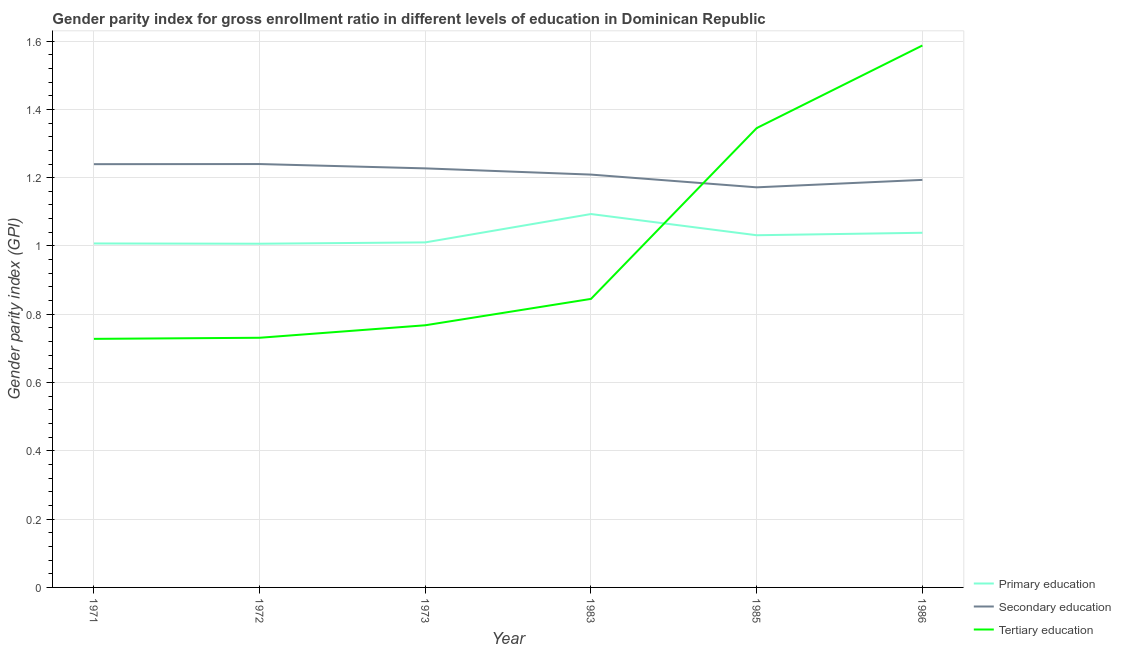Does the line corresponding to gender parity index in primary education intersect with the line corresponding to gender parity index in tertiary education?
Offer a terse response. Yes. Is the number of lines equal to the number of legend labels?
Ensure brevity in your answer.  Yes. What is the gender parity index in tertiary education in 1985?
Provide a short and direct response. 1.35. Across all years, what is the maximum gender parity index in primary education?
Your response must be concise. 1.09. Across all years, what is the minimum gender parity index in primary education?
Offer a terse response. 1.01. What is the total gender parity index in secondary education in the graph?
Give a very brief answer. 7.28. What is the difference between the gender parity index in tertiary education in 1971 and that in 1973?
Make the answer very short. -0.04. What is the difference between the gender parity index in primary education in 1983 and the gender parity index in tertiary education in 1972?
Provide a succinct answer. 0.36. What is the average gender parity index in primary education per year?
Your answer should be compact. 1.03. In the year 1971, what is the difference between the gender parity index in secondary education and gender parity index in primary education?
Your response must be concise. 0.23. What is the ratio of the gender parity index in tertiary education in 1971 to that in 1983?
Make the answer very short. 0.86. Is the difference between the gender parity index in tertiary education in 1972 and 1985 greater than the difference between the gender parity index in primary education in 1972 and 1985?
Your answer should be compact. No. What is the difference between the highest and the second highest gender parity index in tertiary education?
Provide a short and direct response. 0.24. What is the difference between the highest and the lowest gender parity index in primary education?
Your response must be concise. 0.09. In how many years, is the gender parity index in tertiary education greater than the average gender parity index in tertiary education taken over all years?
Give a very brief answer. 2. Is the gender parity index in tertiary education strictly less than the gender parity index in primary education over the years?
Provide a short and direct response. No. How many lines are there?
Keep it short and to the point. 3. How many years are there in the graph?
Provide a succinct answer. 6. Are the values on the major ticks of Y-axis written in scientific E-notation?
Ensure brevity in your answer.  No. Does the graph contain any zero values?
Your response must be concise. No. Does the graph contain grids?
Ensure brevity in your answer.  Yes. Where does the legend appear in the graph?
Your response must be concise. Bottom right. How many legend labels are there?
Make the answer very short. 3. What is the title of the graph?
Ensure brevity in your answer.  Gender parity index for gross enrollment ratio in different levels of education in Dominican Republic. Does "Female employers" appear as one of the legend labels in the graph?
Your answer should be compact. No. What is the label or title of the Y-axis?
Your answer should be compact. Gender parity index (GPI). What is the Gender parity index (GPI) of Primary education in 1971?
Your answer should be compact. 1.01. What is the Gender parity index (GPI) of Secondary education in 1971?
Give a very brief answer. 1.24. What is the Gender parity index (GPI) of Tertiary education in 1971?
Keep it short and to the point. 0.73. What is the Gender parity index (GPI) of Primary education in 1972?
Your response must be concise. 1.01. What is the Gender parity index (GPI) of Secondary education in 1972?
Your answer should be very brief. 1.24. What is the Gender parity index (GPI) of Tertiary education in 1972?
Your answer should be compact. 0.73. What is the Gender parity index (GPI) in Primary education in 1973?
Your answer should be compact. 1.01. What is the Gender parity index (GPI) of Secondary education in 1973?
Offer a terse response. 1.23. What is the Gender parity index (GPI) in Tertiary education in 1973?
Provide a succinct answer. 0.77. What is the Gender parity index (GPI) of Primary education in 1983?
Offer a very short reply. 1.09. What is the Gender parity index (GPI) of Secondary education in 1983?
Give a very brief answer. 1.21. What is the Gender parity index (GPI) in Tertiary education in 1983?
Offer a very short reply. 0.84. What is the Gender parity index (GPI) in Primary education in 1985?
Ensure brevity in your answer.  1.03. What is the Gender parity index (GPI) of Secondary education in 1985?
Make the answer very short. 1.17. What is the Gender parity index (GPI) in Tertiary education in 1985?
Your answer should be very brief. 1.35. What is the Gender parity index (GPI) of Primary education in 1986?
Make the answer very short. 1.04. What is the Gender parity index (GPI) in Secondary education in 1986?
Your answer should be very brief. 1.19. What is the Gender parity index (GPI) in Tertiary education in 1986?
Ensure brevity in your answer.  1.59. Across all years, what is the maximum Gender parity index (GPI) of Primary education?
Keep it short and to the point. 1.09. Across all years, what is the maximum Gender parity index (GPI) of Secondary education?
Make the answer very short. 1.24. Across all years, what is the maximum Gender parity index (GPI) in Tertiary education?
Keep it short and to the point. 1.59. Across all years, what is the minimum Gender parity index (GPI) of Primary education?
Your answer should be very brief. 1.01. Across all years, what is the minimum Gender parity index (GPI) of Secondary education?
Provide a succinct answer. 1.17. Across all years, what is the minimum Gender parity index (GPI) of Tertiary education?
Keep it short and to the point. 0.73. What is the total Gender parity index (GPI) in Primary education in the graph?
Your answer should be very brief. 6.19. What is the total Gender parity index (GPI) of Secondary education in the graph?
Offer a terse response. 7.28. What is the total Gender parity index (GPI) in Tertiary education in the graph?
Offer a terse response. 6. What is the difference between the Gender parity index (GPI) of Primary education in 1971 and that in 1972?
Your response must be concise. 0. What is the difference between the Gender parity index (GPI) in Secondary education in 1971 and that in 1972?
Give a very brief answer. -0. What is the difference between the Gender parity index (GPI) of Tertiary education in 1971 and that in 1972?
Offer a very short reply. -0. What is the difference between the Gender parity index (GPI) of Primary education in 1971 and that in 1973?
Offer a very short reply. -0. What is the difference between the Gender parity index (GPI) in Secondary education in 1971 and that in 1973?
Provide a succinct answer. 0.01. What is the difference between the Gender parity index (GPI) in Tertiary education in 1971 and that in 1973?
Ensure brevity in your answer.  -0.04. What is the difference between the Gender parity index (GPI) of Primary education in 1971 and that in 1983?
Your answer should be compact. -0.09. What is the difference between the Gender parity index (GPI) in Secondary education in 1971 and that in 1983?
Keep it short and to the point. 0.03. What is the difference between the Gender parity index (GPI) of Tertiary education in 1971 and that in 1983?
Make the answer very short. -0.12. What is the difference between the Gender parity index (GPI) in Primary education in 1971 and that in 1985?
Ensure brevity in your answer.  -0.02. What is the difference between the Gender parity index (GPI) in Secondary education in 1971 and that in 1985?
Keep it short and to the point. 0.07. What is the difference between the Gender parity index (GPI) in Tertiary education in 1971 and that in 1985?
Offer a terse response. -0.62. What is the difference between the Gender parity index (GPI) in Primary education in 1971 and that in 1986?
Your response must be concise. -0.03. What is the difference between the Gender parity index (GPI) in Secondary education in 1971 and that in 1986?
Provide a short and direct response. 0.05. What is the difference between the Gender parity index (GPI) in Tertiary education in 1971 and that in 1986?
Give a very brief answer. -0.86. What is the difference between the Gender parity index (GPI) of Primary education in 1972 and that in 1973?
Offer a very short reply. -0. What is the difference between the Gender parity index (GPI) of Secondary education in 1972 and that in 1973?
Offer a terse response. 0.01. What is the difference between the Gender parity index (GPI) of Tertiary education in 1972 and that in 1973?
Give a very brief answer. -0.04. What is the difference between the Gender parity index (GPI) in Primary education in 1972 and that in 1983?
Your answer should be very brief. -0.09. What is the difference between the Gender parity index (GPI) in Secondary education in 1972 and that in 1983?
Your answer should be compact. 0.03. What is the difference between the Gender parity index (GPI) in Tertiary education in 1972 and that in 1983?
Keep it short and to the point. -0.11. What is the difference between the Gender parity index (GPI) in Primary education in 1972 and that in 1985?
Your response must be concise. -0.02. What is the difference between the Gender parity index (GPI) in Secondary education in 1972 and that in 1985?
Make the answer very short. 0.07. What is the difference between the Gender parity index (GPI) of Tertiary education in 1972 and that in 1985?
Provide a short and direct response. -0.61. What is the difference between the Gender parity index (GPI) of Primary education in 1972 and that in 1986?
Ensure brevity in your answer.  -0.03. What is the difference between the Gender parity index (GPI) of Secondary education in 1972 and that in 1986?
Offer a very short reply. 0.05. What is the difference between the Gender parity index (GPI) of Tertiary education in 1972 and that in 1986?
Provide a succinct answer. -0.86. What is the difference between the Gender parity index (GPI) in Primary education in 1973 and that in 1983?
Your answer should be compact. -0.08. What is the difference between the Gender parity index (GPI) of Secondary education in 1973 and that in 1983?
Offer a very short reply. 0.02. What is the difference between the Gender parity index (GPI) in Tertiary education in 1973 and that in 1983?
Offer a terse response. -0.08. What is the difference between the Gender parity index (GPI) in Primary education in 1973 and that in 1985?
Offer a very short reply. -0.02. What is the difference between the Gender parity index (GPI) of Secondary education in 1973 and that in 1985?
Offer a very short reply. 0.06. What is the difference between the Gender parity index (GPI) in Tertiary education in 1973 and that in 1985?
Offer a very short reply. -0.58. What is the difference between the Gender parity index (GPI) in Primary education in 1973 and that in 1986?
Provide a succinct answer. -0.03. What is the difference between the Gender parity index (GPI) of Secondary education in 1973 and that in 1986?
Provide a short and direct response. 0.03. What is the difference between the Gender parity index (GPI) in Tertiary education in 1973 and that in 1986?
Provide a succinct answer. -0.82. What is the difference between the Gender parity index (GPI) of Primary education in 1983 and that in 1985?
Offer a terse response. 0.06. What is the difference between the Gender parity index (GPI) of Secondary education in 1983 and that in 1985?
Your answer should be very brief. 0.04. What is the difference between the Gender parity index (GPI) in Tertiary education in 1983 and that in 1985?
Offer a terse response. -0.5. What is the difference between the Gender parity index (GPI) of Primary education in 1983 and that in 1986?
Offer a terse response. 0.05. What is the difference between the Gender parity index (GPI) in Secondary education in 1983 and that in 1986?
Your response must be concise. 0.02. What is the difference between the Gender parity index (GPI) in Tertiary education in 1983 and that in 1986?
Give a very brief answer. -0.74. What is the difference between the Gender parity index (GPI) in Primary education in 1985 and that in 1986?
Offer a very short reply. -0.01. What is the difference between the Gender parity index (GPI) of Secondary education in 1985 and that in 1986?
Ensure brevity in your answer.  -0.02. What is the difference between the Gender parity index (GPI) in Tertiary education in 1985 and that in 1986?
Your response must be concise. -0.24. What is the difference between the Gender parity index (GPI) of Primary education in 1971 and the Gender parity index (GPI) of Secondary education in 1972?
Your answer should be very brief. -0.23. What is the difference between the Gender parity index (GPI) of Primary education in 1971 and the Gender parity index (GPI) of Tertiary education in 1972?
Ensure brevity in your answer.  0.28. What is the difference between the Gender parity index (GPI) in Secondary education in 1971 and the Gender parity index (GPI) in Tertiary education in 1972?
Offer a terse response. 0.51. What is the difference between the Gender parity index (GPI) of Primary education in 1971 and the Gender parity index (GPI) of Secondary education in 1973?
Keep it short and to the point. -0.22. What is the difference between the Gender parity index (GPI) in Primary education in 1971 and the Gender parity index (GPI) in Tertiary education in 1973?
Your answer should be compact. 0.24. What is the difference between the Gender parity index (GPI) of Secondary education in 1971 and the Gender parity index (GPI) of Tertiary education in 1973?
Give a very brief answer. 0.47. What is the difference between the Gender parity index (GPI) in Primary education in 1971 and the Gender parity index (GPI) in Secondary education in 1983?
Provide a short and direct response. -0.2. What is the difference between the Gender parity index (GPI) in Primary education in 1971 and the Gender parity index (GPI) in Tertiary education in 1983?
Your answer should be compact. 0.16. What is the difference between the Gender parity index (GPI) of Secondary education in 1971 and the Gender parity index (GPI) of Tertiary education in 1983?
Offer a very short reply. 0.39. What is the difference between the Gender parity index (GPI) in Primary education in 1971 and the Gender parity index (GPI) in Secondary education in 1985?
Your answer should be compact. -0.16. What is the difference between the Gender parity index (GPI) in Primary education in 1971 and the Gender parity index (GPI) in Tertiary education in 1985?
Ensure brevity in your answer.  -0.34. What is the difference between the Gender parity index (GPI) of Secondary education in 1971 and the Gender parity index (GPI) of Tertiary education in 1985?
Offer a very short reply. -0.11. What is the difference between the Gender parity index (GPI) in Primary education in 1971 and the Gender parity index (GPI) in Secondary education in 1986?
Your answer should be very brief. -0.19. What is the difference between the Gender parity index (GPI) in Primary education in 1971 and the Gender parity index (GPI) in Tertiary education in 1986?
Provide a succinct answer. -0.58. What is the difference between the Gender parity index (GPI) in Secondary education in 1971 and the Gender parity index (GPI) in Tertiary education in 1986?
Keep it short and to the point. -0.35. What is the difference between the Gender parity index (GPI) of Primary education in 1972 and the Gender parity index (GPI) of Secondary education in 1973?
Provide a succinct answer. -0.22. What is the difference between the Gender parity index (GPI) of Primary education in 1972 and the Gender parity index (GPI) of Tertiary education in 1973?
Keep it short and to the point. 0.24. What is the difference between the Gender parity index (GPI) in Secondary education in 1972 and the Gender parity index (GPI) in Tertiary education in 1973?
Give a very brief answer. 0.47. What is the difference between the Gender parity index (GPI) of Primary education in 1972 and the Gender parity index (GPI) of Secondary education in 1983?
Ensure brevity in your answer.  -0.2. What is the difference between the Gender parity index (GPI) in Primary education in 1972 and the Gender parity index (GPI) in Tertiary education in 1983?
Provide a short and direct response. 0.16. What is the difference between the Gender parity index (GPI) of Secondary education in 1972 and the Gender parity index (GPI) of Tertiary education in 1983?
Provide a short and direct response. 0.39. What is the difference between the Gender parity index (GPI) of Primary education in 1972 and the Gender parity index (GPI) of Secondary education in 1985?
Keep it short and to the point. -0.17. What is the difference between the Gender parity index (GPI) of Primary education in 1972 and the Gender parity index (GPI) of Tertiary education in 1985?
Provide a succinct answer. -0.34. What is the difference between the Gender parity index (GPI) of Secondary education in 1972 and the Gender parity index (GPI) of Tertiary education in 1985?
Your answer should be compact. -0.11. What is the difference between the Gender parity index (GPI) in Primary education in 1972 and the Gender parity index (GPI) in Secondary education in 1986?
Give a very brief answer. -0.19. What is the difference between the Gender parity index (GPI) of Primary education in 1972 and the Gender parity index (GPI) of Tertiary education in 1986?
Ensure brevity in your answer.  -0.58. What is the difference between the Gender parity index (GPI) in Secondary education in 1972 and the Gender parity index (GPI) in Tertiary education in 1986?
Your answer should be very brief. -0.35. What is the difference between the Gender parity index (GPI) in Primary education in 1973 and the Gender parity index (GPI) in Secondary education in 1983?
Provide a short and direct response. -0.2. What is the difference between the Gender parity index (GPI) of Primary education in 1973 and the Gender parity index (GPI) of Tertiary education in 1983?
Give a very brief answer. 0.17. What is the difference between the Gender parity index (GPI) in Secondary education in 1973 and the Gender parity index (GPI) in Tertiary education in 1983?
Your answer should be compact. 0.38. What is the difference between the Gender parity index (GPI) of Primary education in 1973 and the Gender parity index (GPI) of Secondary education in 1985?
Ensure brevity in your answer.  -0.16. What is the difference between the Gender parity index (GPI) of Primary education in 1973 and the Gender parity index (GPI) of Tertiary education in 1985?
Offer a terse response. -0.33. What is the difference between the Gender parity index (GPI) of Secondary education in 1973 and the Gender parity index (GPI) of Tertiary education in 1985?
Provide a succinct answer. -0.12. What is the difference between the Gender parity index (GPI) of Primary education in 1973 and the Gender parity index (GPI) of Secondary education in 1986?
Provide a succinct answer. -0.18. What is the difference between the Gender parity index (GPI) in Primary education in 1973 and the Gender parity index (GPI) in Tertiary education in 1986?
Provide a short and direct response. -0.58. What is the difference between the Gender parity index (GPI) of Secondary education in 1973 and the Gender parity index (GPI) of Tertiary education in 1986?
Your response must be concise. -0.36. What is the difference between the Gender parity index (GPI) in Primary education in 1983 and the Gender parity index (GPI) in Secondary education in 1985?
Offer a terse response. -0.08. What is the difference between the Gender parity index (GPI) in Primary education in 1983 and the Gender parity index (GPI) in Tertiary education in 1985?
Provide a succinct answer. -0.25. What is the difference between the Gender parity index (GPI) of Secondary education in 1983 and the Gender parity index (GPI) of Tertiary education in 1985?
Keep it short and to the point. -0.14. What is the difference between the Gender parity index (GPI) of Primary education in 1983 and the Gender parity index (GPI) of Tertiary education in 1986?
Provide a succinct answer. -0.49. What is the difference between the Gender parity index (GPI) of Secondary education in 1983 and the Gender parity index (GPI) of Tertiary education in 1986?
Give a very brief answer. -0.38. What is the difference between the Gender parity index (GPI) of Primary education in 1985 and the Gender parity index (GPI) of Secondary education in 1986?
Offer a terse response. -0.16. What is the difference between the Gender parity index (GPI) of Primary education in 1985 and the Gender parity index (GPI) of Tertiary education in 1986?
Give a very brief answer. -0.56. What is the difference between the Gender parity index (GPI) of Secondary education in 1985 and the Gender parity index (GPI) of Tertiary education in 1986?
Provide a succinct answer. -0.42. What is the average Gender parity index (GPI) in Primary education per year?
Offer a terse response. 1.03. What is the average Gender parity index (GPI) in Secondary education per year?
Provide a succinct answer. 1.21. In the year 1971, what is the difference between the Gender parity index (GPI) in Primary education and Gender parity index (GPI) in Secondary education?
Your answer should be compact. -0.23. In the year 1971, what is the difference between the Gender parity index (GPI) of Primary education and Gender parity index (GPI) of Tertiary education?
Provide a succinct answer. 0.28. In the year 1971, what is the difference between the Gender parity index (GPI) of Secondary education and Gender parity index (GPI) of Tertiary education?
Make the answer very short. 0.51. In the year 1972, what is the difference between the Gender parity index (GPI) of Primary education and Gender parity index (GPI) of Secondary education?
Offer a very short reply. -0.23. In the year 1972, what is the difference between the Gender parity index (GPI) in Primary education and Gender parity index (GPI) in Tertiary education?
Keep it short and to the point. 0.28. In the year 1972, what is the difference between the Gender parity index (GPI) of Secondary education and Gender parity index (GPI) of Tertiary education?
Ensure brevity in your answer.  0.51. In the year 1973, what is the difference between the Gender parity index (GPI) in Primary education and Gender parity index (GPI) in Secondary education?
Your answer should be very brief. -0.22. In the year 1973, what is the difference between the Gender parity index (GPI) in Primary education and Gender parity index (GPI) in Tertiary education?
Your answer should be very brief. 0.24. In the year 1973, what is the difference between the Gender parity index (GPI) of Secondary education and Gender parity index (GPI) of Tertiary education?
Provide a short and direct response. 0.46. In the year 1983, what is the difference between the Gender parity index (GPI) in Primary education and Gender parity index (GPI) in Secondary education?
Give a very brief answer. -0.12. In the year 1983, what is the difference between the Gender parity index (GPI) in Primary education and Gender parity index (GPI) in Tertiary education?
Offer a terse response. 0.25. In the year 1983, what is the difference between the Gender parity index (GPI) in Secondary education and Gender parity index (GPI) in Tertiary education?
Offer a terse response. 0.36. In the year 1985, what is the difference between the Gender parity index (GPI) of Primary education and Gender parity index (GPI) of Secondary education?
Give a very brief answer. -0.14. In the year 1985, what is the difference between the Gender parity index (GPI) of Primary education and Gender parity index (GPI) of Tertiary education?
Your answer should be compact. -0.31. In the year 1985, what is the difference between the Gender parity index (GPI) of Secondary education and Gender parity index (GPI) of Tertiary education?
Your response must be concise. -0.17. In the year 1986, what is the difference between the Gender parity index (GPI) in Primary education and Gender parity index (GPI) in Secondary education?
Make the answer very short. -0.15. In the year 1986, what is the difference between the Gender parity index (GPI) in Primary education and Gender parity index (GPI) in Tertiary education?
Give a very brief answer. -0.55. In the year 1986, what is the difference between the Gender parity index (GPI) in Secondary education and Gender parity index (GPI) in Tertiary education?
Your answer should be compact. -0.39. What is the ratio of the Gender parity index (GPI) in Primary education in 1971 to that in 1972?
Offer a very short reply. 1. What is the ratio of the Gender parity index (GPI) in Tertiary education in 1971 to that in 1973?
Keep it short and to the point. 0.95. What is the ratio of the Gender parity index (GPI) in Primary education in 1971 to that in 1983?
Give a very brief answer. 0.92. What is the ratio of the Gender parity index (GPI) in Secondary education in 1971 to that in 1983?
Offer a very short reply. 1.03. What is the ratio of the Gender parity index (GPI) of Tertiary education in 1971 to that in 1983?
Keep it short and to the point. 0.86. What is the ratio of the Gender parity index (GPI) of Primary education in 1971 to that in 1985?
Ensure brevity in your answer.  0.98. What is the ratio of the Gender parity index (GPI) of Secondary education in 1971 to that in 1985?
Make the answer very short. 1.06. What is the ratio of the Gender parity index (GPI) of Tertiary education in 1971 to that in 1985?
Your answer should be very brief. 0.54. What is the ratio of the Gender parity index (GPI) of Primary education in 1971 to that in 1986?
Offer a terse response. 0.97. What is the ratio of the Gender parity index (GPI) in Secondary education in 1971 to that in 1986?
Provide a succinct answer. 1.04. What is the ratio of the Gender parity index (GPI) of Tertiary education in 1971 to that in 1986?
Ensure brevity in your answer.  0.46. What is the ratio of the Gender parity index (GPI) of Primary education in 1972 to that in 1973?
Your answer should be very brief. 1. What is the ratio of the Gender parity index (GPI) of Secondary education in 1972 to that in 1973?
Your answer should be very brief. 1.01. What is the ratio of the Gender parity index (GPI) in Tertiary education in 1972 to that in 1973?
Your response must be concise. 0.95. What is the ratio of the Gender parity index (GPI) in Primary education in 1972 to that in 1983?
Offer a terse response. 0.92. What is the ratio of the Gender parity index (GPI) in Secondary education in 1972 to that in 1983?
Your answer should be compact. 1.03. What is the ratio of the Gender parity index (GPI) in Tertiary education in 1972 to that in 1983?
Give a very brief answer. 0.87. What is the ratio of the Gender parity index (GPI) in Primary education in 1972 to that in 1985?
Your answer should be very brief. 0.98. What is the ratio of the Gender parity index (GPI) in Secondary education in 1972 to that in 1985?
Your answer should be very brief. 1.06. What is the ratio of the Gender parity index (GPI) of Tertiary education in 1972 to that in 1985?
Keep it short and to the point. 0.54. What is the ratio of the Gender parity index (GPI) in Primary education in 1972 to that in 1986?
Offer a very short reply. 0.97. What is the ratio of the Gender parity index (GPI) in Secondary education in 1972 to that in 1986?
Your answer should be very brief. 1.04. What is the ratio of the Gender parity index (GPI) in Tertiary education in 1972 to that in 1986?
Your answer should be compact. 0.46. What is the ratio of the Gender parity index (GPI) in Primary education in 1973 to that in 1983?
Offer a terse response. 0.92. What is the ratio of the Gender parity index (GPI) in Secondary education in 1973 to that in 1983?
Provide a short and direct response. 1.02. What is the ratio of the Gender parity index (GPI) of Tertiary education in 1973 to that in 1983?
Offer a terse response. 0.91. What is the ratio of the Gender parity index (GPI) of Primary education in 1973 to that in 1985?
Your answer should be compact. 0.98. What is the ratio of the Gender parity index (GPI) in Secondary education in 1973 to that in 1985?
Keep it short and to the point. 1.05. What is the ratio of the Gender parity index (GPI) in Tertiary education in 1973 to that in 1985?
Your response must be concise. 0.57. What is the ratio of the Gender parity index (GPI) of Primary education in 1973 to that in 1986?
Make the answer very short. 0.97. What is the ratio of the Gender parity index (GPI) of Secondary education in 1973 to that in 1986?
Provide a succinct answer. 1.03. What is the ratio of the Gender parity index (GPI) of Tertiary education in 1973 to that in 1986?
Your response must be concise. 0.48. What is the ratio of the Gender parity index (GPI) in Primary education in 1983 to that in 1985?
Your answer should be compact. 1.06. What is the ratio of the Gender parity index (GPI) of Secondary education in 1983 to that in 1985?
Keep it short and to the point. 1.03. What is the ratio of the Gender parity index (GPI) in Tertiary education in 1983 to that in 1985?
Your answer should be very brief. 0.63. What is the ratio of the Gender parity index (GPI) of Primary education in 1983 to that in 1986?
Offer a very short reply. 1.05. What is the ratio of the Gender parity index (GPI) in Tertiary education in 1983 to that in 1986?
Offer a very short reply. 0.53. What is the ratio of the Gender parity index (GPI) in Secondary education in 1985 to that in 1986?
Keep it short and to the point. 0.98. What is the ratio of the Gender parity index (GPI) of Tertiary education in 1985 to that in 1986?
Give a very brief answer. 0.85. What is the difference between the highest and the second highest Gender parity index (GPI) of Primary education?
Provide a short and direct response. 0.05. What is the difference between the highest and the second highest Gender parity index (GPI) of Tertiary education?
Give a very brief answer. 0.24. What is the difference between the highest and the lowest Gender parity index (GPI) in Primary education?
Make the answer very short. 0.09. What is the difference between the highest and the lowest Gender parity index (GPI) in Secondary education?
Keep it short and to the point. 0.07. What is the difference between the highest and the lowest Gender parity index (GPI) in Tertiary education?
Keep it short and to the point. 0.86. 